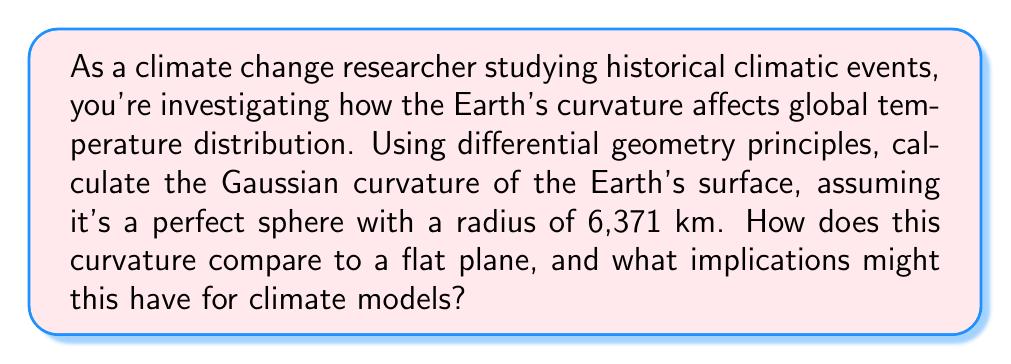Help me with this question. To calculate the Gaussian curvature of the Earth's surface using differential geometry principles, we'll follow these steps:

1. Recall that for a sphere, the Gaussian curvature $K$ is constant and given by:

   $$K = \frac{1}{R^2}$$

   where $R$ is the radius of the sphere.

2. Given the Earth's radius of 6,371 km, we can substitute this value:

   $$K = \frac{1}{(6,371 \text{ km})^2}$$

3. Simplify:
   
   $$K = \frac{1}{40,589,641 \text{ km}^2} \approx 2.46 \times 10^{-14} \text{ km}^{-2}$$

4. To compare this to a flat plane, recall that a flat surface has zero Gaussian curvature. The Earth's positive curvature indicates that it's locally convex at every point, unlike a flat plane.

5. Implications for climate models:
   a) The curvature affects how solar radiation is distributed across the Earth's surface.
   b) It influences atmospheric and oceanic circulation patterns.
   c) Models must account for this curvature when simulating global climate systems.
   d) Historical climate events may have been influenced by this curvature, especially in terms of heat distribution and weather patterns.
Answer: $K \approx 2.46 \times 10^{-14} \text{ km}^{-2}$ 